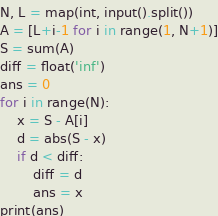Convert code to text. <code><loc_0><loc_0><loc_500><loc_500><_Python_>N, L = map(int, input().split())
A = [L+i-1 for i in range(1, N+1)]
S = sum(A)
diff = float('inf')
ans = 0
for i in range(N):
    x = S - A[i]
    d = abs(S - x)
    if d < diff:
        diff = d
        ans = x
print(ans)</code> 